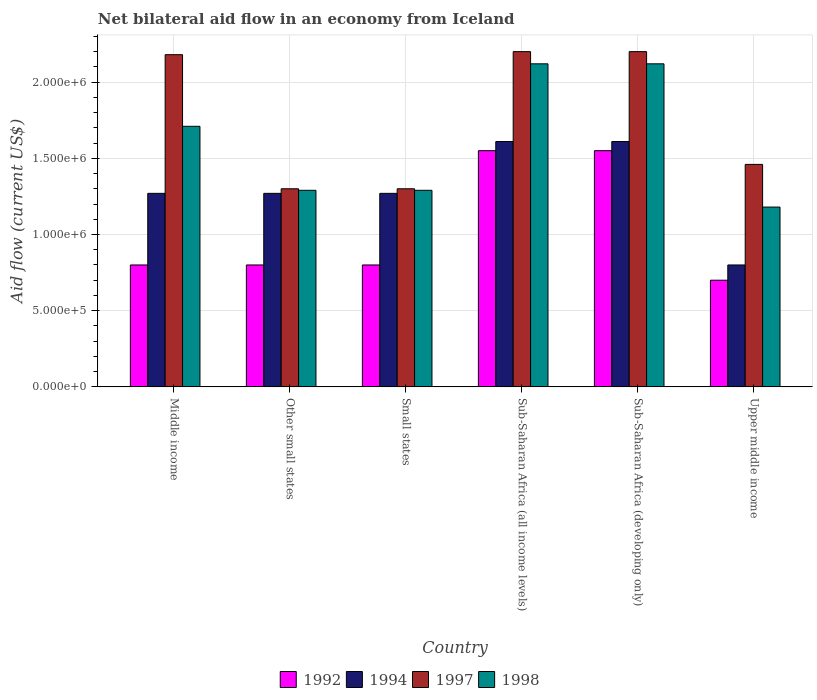Are the number of bars on each tick of the X-axis equal?
Make the answer very short. Yes. How many bars are there on the 1st tick from the left?
Give a very brief answer. 4. What is the label of the 5th group of bars from the left?
Offer a very short reply. Sub-Saharan Africa (developing only). What is the net bilateral aid flow in 1994 in Small states?
Give a very brief answer. 1.27e+06. Across all countries, what is the maximum net bilateral aid flow in 1997?
Your answer should be very brief. 2.20e+06. Across all countries, what is the minimum net bilateral aid flow in 1992?
Provide a succinct answer. 7.00e+05. In which country was the net bilateral aid flow in 1998 maximum?
Make the answer very short. Sub-Saharan Africa (all income levels). In which country was the net bilateral aid flow in 1994 minimum?
Make the answer very short. Upper middle income. What is the total net bilateral aid flow in 1998 in the graph?
Provide a succinct answer. 9.71e+06. What is the difference between the net bilateral aid flow in 1994 in Small states and the net bilateral aid flow in 1997 in Middle income?
Ensure brevity in your answer.  -9.10e+05. What is the average net bilateral aid flow in 1998 per country?
Offer a terse response. 1.62e+06. What is the difference between the net bilateral aid flow of/in 1994 and net bilateral aid flow of/in 1997 in Sub-Saharan Africa (all income levels)?
Your answer should be very brief. -5.90e+05. In how many countries, is the net bilateral aid flow in 1998 greater than 1300000 US$?
Ensure brevity in your answer.  3. What is the ratio of the net bilateral aid flow in 1998 in Middle income to that in Sub-Saharan Africa (developing only)?
Provide a short and direct response. 0.81. What is the difference between the highest and the second highest net bilateral aid flow in 1998?
Ensure brevity in your answer.  4.10e+05. What is the difference between the highest and the lowest net bilateral aid flow in 1997?
Offer a terse response. 9.00e+05. In how many countries, is the net bilateral aid flow in 1998 greater than the average net bilateral aid flow in 1998 taken over all countries?
Keep it short and to the point. 3. Is the sum of the net bilateral aid flow in 1997 in Small states and Upper middle income greater than the maximum net bilateral aid flow in 1998 across all countries?
Ensure brevity in your answer.  Yes. What does the 4th bar from the left in Other small states represents?
Your answer should be very brief. 1998. What does the 3rd bar from the right in Sub-Saharan Africa (all income levels) represents?
Provide a succinct answer. 1994. Are all the bars in the graph horizontal?
Make the answer very short. No. Does the graph contain grids?
Make the answer very short. Yes. How many legend labels are there?
Offer a terse response. 4. How are the legend labels stacked?
Your answer should be compact. Horizontal. What is the title of the graph?
Provide a short and direct response. Net bilateral aid flow in an economy from Iceland. Does "1993" appear as one of the legend labels in the graph?
Keep it short and to the point. No. What is the Aid flow (current US$) in 1994 in Middle income?
Keep it short and to the point. 1.27e+06. What is the Aid flow (current US$) of 1997 in Middle income?
Give a very brief answer. 2.18e+06. What is the Aid flow (current US$) in 1998 in Middle income?
Offer a terse response. 1.71e+06. What is the Aid flow (current US$) of 1994 in Other small states?
Provide a succinct answer. 1.27e+06. What is the Aid flow (current US$) of 1997 in Other small states?
Ensure brevity in your answer.  1.30e+06. What is the Aid flow (current US$) of 1998 in Other small states?
Your response must be concise. 1.29e+06. What is the Aid flow (current US$) in 1994 in Small states?
Your answer should be very brief. 1.27e+06. What is the Aid flow (current US$) of 1997 in Small states?
Provide a short and direct response. 1.30e+06. What is the Aid flow (current US$) of 1998 in Small states?
Offer a very short reply. 1.29e+06. What is the Aid flow (current US$) in 1992 in Sub-Saharan Africa (all income levels)?
Keep it short and to the point. 1.55e+06. What is the Aid flow (current US$) in 1994 in Sub-Saharan Africa (all income levels)?
Offer a very short reply. 1.61e+06. What is the Aid flow (current US$) in 1997 in Sub-Saharan Africa (all income levels)?
Keep it short and to the point. 2.20e+06. What is the Aid flow (current US$) in 1998 in Sub-Saharan Africa (all income levels)?
Provide a succinct answer. 2.12e+06. What is the Aid flow (current US$) of 1992 in Sub-Saharan Africa (developing only)?
Keep it short and to the point. 1.55e+06. What is the Aid flow (current US$) in 1994 in Sub-Saharan Africa (developing only)?
Give a very brief answer. 1.61e+06. What is the Aid flow (current US$) of 1997 in Sub-Saharan Africa (developing only)?
Your answer should be very brief. 2.20e+06. What is the Aid flow (current US$) in 1998 in Sub-Saharan Africa (developing only)?
Your answer should be very brief. 2.12e+06. What is the Aid flow (current US$) in 1994 in Upper middle income?
Provide a succinct answer. 8.00e+05. What is the Aid flow (current US$) in 1997 in Upper middle income?
Your response must be concise. 1.46e+06. What is the Aid flow (current US$) of 1998 in Upper middle income?
Offer a very short reply. 1.18e+06. Across all countries, what is the maximum Aid flow (current US$) in 1992?
Offer a terse response. 1.55e+06. Across all countries, what is the maximum Aid flow (current US$) of 1994?
Give a very brief answer. 1.61e+06. Across all countries, what is the maximum Aid flow (current US$) in 1997?
Keep it short and to the point. 2.20e+06. Across all countries, what is the maximum Aid flow (current US$) of 1998?
Provide a short and direct response. 2.12e+06. Across all countries, what is the minimum Aid flow (current US$) in 1992?
Offer a very short reply. 7.00e+05. Across all countries, what is the minimum Aid flow (current US$) of 1997?
Your answer should be compact. 1.30e+06. Across all countries, what is the minimum Aid flow (current US$) in 1998?
Make the answer very short. 1.18e+06. What is the total Aid flow (current US$) of 1992 in the graph?
Your answer should be compact. 6.20e+06. What is the total Aid flow (current US$) of 1994 in the graph?
Provide a short and direct response. 7.83e+06. What is the total Aid flow (current US$) in 1997 in the graph?
Your answer should be very brief. 1.06e+07. What is the total Aid flow (current US$) in 1998 in the graph?
Give a very brief answer. 9.71e+06. What is the difference between the Aid flow (current US$) in 1992 in Middle income and that in Other small states?
Ensure brevity in your answer.  0. What is the difference between the Aid flow (current US$) of 1997 in Middle income and that in Other small states?
Provide a short and direct response. 8.80e+05. What is the difference between the Aid flow (current US$) in 1998 in Middle income and that in Other small states?
Offer a terse response. 4.20e+05. What is the difference between the Aid flow (current US$) in 1992 in Middle income and that in Small states?
Your response must be concise. 0. What is the difference between the Aid flow (current US$) in 1997 in Middle income and that in Small states?
Your answer should be compact. 8.80e+05. What is the difference between the Aid flow (current US$) in 1992 in Middle income and that in Sub-Saharan Africa (all income levels)?
Keep it short and to the point. -7.50e+05. What is the difference between the Aid flow (current US$) in 1994 in Middle income and that in Sub-Saharan Africa (all income levels)?
Keep it short and to the point. -3.40e+05. What is the difference between the Aid flow (current US$) in 1997 in Middle income and that in Sub-Saharan Africa (all income levels)?
Provide a succinct answer. -2.00e+04. What is the difference between the Aid flow (current US$) in 1998 in Middle income and that in Sub-Saharan Africa (all income levels)?
Ensure brevity in your answer.  -4.10e+05. What is the difference between the Aid flow (current US$) in 1992 in Middle income and that in Sub-Saharan Africa (developing only)?
Your answer should be compact. -7.50e+05. What is the difference between the Aid flow (current US$) of 1994 in Middle income and that in Sub-Saharan Africa (developing only)?
Make the answer very short. -3.40e+05. What is the difference between the Aid flow (current US$) in 1997 in Middle income and that in Sub-Saharan Africa (developing only)?
Your response must be concise. -2.00e+04. What is the difference between the Aid flow (current US$) of 1998 in Middle income and that in Sub-Saharan Africa (developing only)?
Your answer should be very brief. -4.10e+05. What is the difference between the Aid flow (current US$) of 1994 in Middle income and that in Upper middle income?
Keep it short and to the point. 4.70e+05. What is the difference between the Aid flow (current US$) in 1997 in Middle income and that in Upper middle income?
Your answer should be very brief. 7.20e+05. What is the difference between the Aid flow (current US$) in 1998 in Middle income and that in Upper middle income?
Provide a succinct answer. 5.30e+05. What is the difference between the Aid flow (current US$) of 1998 in Other small states and that in Small states?
Provide a short and direct response. 0. What is the difference between the Aid flow (current US$) of 1992 in Other small states and that in Sub-Saharan Africa (all income levels)?
Your response must be concise. -7.50e+05. What is the difference between the Aid flow (current US$) in 1997 in Other small states and that in Sub-Saharan Africa (all income levels)?
Provide a succinct answer. -9.00e+05. What is the difference between the Aid flow (current US$) of 1998 in Other small states and that in Sub-Saharan Africa (all income levels)?
Your response must be concise. -8.30e+05. What is the difference between the Aid flow (current US$) in 1992 in Other small states and that in Sub-Saharan Africa (developing only)?
Your answer should be compact. -7.50e+05. What is the difference between the Aid flow (current US$) of 1994 in Other small states and that in Sub-Saharan Africa (developing only)?
Keep it short and to the point. -3.40e+05. What is the difference between the Aid flow (current US$) of 1997 in Other small states and that in Sub-Saharan Africa (developing only)?
Provide a short and direct response. -9.00e+05. What is the difference between the Aid flow (current US$) of 1998 in Other small states and that in Sub-Saharan Africa (developing only)?
Your response must be concise. -8.30e+05. What is the difference between the Aid flow (current US$) in 1992 in Other small states and that in Upper middle income?
Provide a succinct answer. 1.00e+05. What is the difference between the Aid flow (current US$) of 1994 in Other small states and that in Upper middle income?
Your answer should be very brief. 4.70e+05. What is the difference between the Aid flow (current US$) of 1997 in Other small states and that in Upper middle income?
Offer a terse response. -1.60e+05. What is the difference between the Aid flow (current US$) in 1992 in Small states and that in Sub-Saharan Africa (all income levels)?
Your answer should be very brief. -7.50e+05. What is the difference between the Aid flow (current US$) in 1997 in Small states and that in Sub-Saharan Africa (all income levels)?
Give a very brief answer. -9.00e+05. What is the difference between the Aid flow (current US$) of 1998 in Small states and that in Sub-Saharan Africa (all income levels)?
Your answer should be compact. -8.30e+05. What is the difference between the Aid flow (current US$) of 1992 in Small states and that in Sub-Saharan Africa (developing only)?
Give a very brief answer. -7.50e+05. What is the difference between the Aid flow (current US$) in 1997 in Small states and that in Sub-Saharan Africa (developing only)?
Offer a very short reply. -9.00e+05. What is the difference between the Aid flow (current US$) of 1998 in Small states and that in Sub-Saharan Africa (developing only)?
Offer a terse response. -8.30e+05. What is the difference between the Aid flow (current US$) in 1998 in Small states and that in Upper middle income?
Provide a short and direct response. 1.10e+05. What is the difference between the Aid flow (current US$) in 1992 in Sub-Saharan Africa (all income levels) and that in Sub-Saharan Africa (developing only)?
Provide a short and direct response. 0. What is the difference between the Aid flow (current US$) of 1998 in Sub-Saharan Africa (all income levels) and that in Sub-Saharan Africa (developing only)?
Keep it short and to the point. 0. What is the difference between the Aid flow (current US$) of 1992 in Sub-Saharan Africa (all income levels) and that in Upper middle income?
Your response must be concise. 8.50e+05. What is the difference between the Aid flow (current US$) of 1994 in Sub-Saharan Africa (all income levels) and that in Upper middle income?
Your response must be concise. 8.10e+05. What is the difference between the Aid flow (current US$) in 1997 in Sub-Saharan Africa (all income levels) and that in Upper middle income?
Keep it short and to the point. 7.40e+05. What is the difference between the Aid flow (current US$) of 1998 in Sub-Saharan Africa (all income levels) and that in Upper middle income?
Offer a terse response. 9.40e+05. What is the difference between the Aid flow (current US$) in 1992 in Sub-Saharan Africa (developing only) and that in Upper middle income?
Keep it short and to the point. 8.50e+05. What is the difference between the Aid flow (current US$) of 1994 in Sub-Saharan Africa (developing only) and that in Upper middle income?
Keep it short and to the point. 8.10e+05. What is the difference between the Aid flow (current US$) of 1997 in Sub-Saharan Africa (developing only) and that in Upper middle income?
Your answer should be very brief. 7.40e+05. What is the difference between the Aid flow (current US$) of 1998 in Sub-Saharan Africa (developing only) and that in Upper middle income?
Give a very brief answer. 9.40e+05. What is the difference between the Aid flow (current US$) in 1992 in Middle income and the Aid flow (current US$) in 1994 in Other small states?
Your answer should be very brief. -4.70e+05. What is the difference between the Aid flow (current US$) in 1992 in Middle income and the Aid flow (current US$) in 1997 in Other small states?
Ensure brevity in your answer.  -5.00e+05. What is the difference between the Aid flow (current US$) of 1992 in Middle income and the Aid flow (current US$) of 1998 in Other small states?
Ensure brevity in your answer.  -4.90e+05. What is the difference between the Aid flow (current US$) in 1997 in Middle income and the Aid flow (current US$) in 1998 in Other small states?
Offer a terse response. 8.90e+05. What is the difference between the Aid flow (current US$) in 1992 in Middle income and the Aid flow (current US$) in 1994 in Small states?
Provide a succinct answer. -4.70e+05. What is the difference between the Aid flow (current US$) in 1992 in Middle income and the Aid flow (current US$) in 1997 in Small states?
Provide a short and direct response. -5.00e+05. What is the difference between the Aid flow (current US$) of 1992 in Middle income and the Aid flow (current US$) of 1998 in Small states?
Make the answer very short. -4.90e+05. What is the difference between the Aid flow (current US$) of 1994 in Middle income and the Aid flow (current US$) of 1998 in Small states?
Provide a succinct answer. -2.00e+04. What is the difference between the Aid flow (current US$) in 1997 in Middle income and the Aid flow (current US$) in 1998 in Small states?
Your response must be concise. 8.90e+05. What is the difference between the Aid flow (current US$) of 1992 in Middle income and the Aid flow (current US$) of 1994 in Sub-Saharan Africa (all income levels)?
Your response must be concise. -8.10e+05. What is the difference between the Aid flow (current US$) of 1992 in Middle income and the Aid flow (current US$) of 1997 in Sub-Saharan Africa (all income levels)?
Give a very brief answer. -1.40e+06. What is the difference between the Aid flow (current US$) in 1992 in Middle income and the Aid flow (current US$) in 1998 in Sub-Saharan Africa (all income levels)?
Your answer should be very brief. -1.32e+06. What is the difference between the Aid flow (current US$) in 1994 in Middle income and the Aid flow (current US$) in 1997 in Sub-Saharan Africa (all income levels)?
Your response must be concise. -9.30e+05. What is the difference between the Aid flow (current US$) in 1994 in Middle income and the Aid flow (current US$) in 1998 in Sub-Saharan Africa (all income levels)?
Provide a short and direct response. -8.50e+05. What is the difference between the Aid flow (current US$) in 1992 in Middle income and the Aid flow (current US$) in 1994 in Sub-Saharan Africa (developing only)?
Provide a short and direct response. -8.10e+05. What is the difference between the Aid flow (current US$) in 1992 in Middle income and the Aid flow (current US$) in 1997 in Sub-Saharan Africa (developing only)?
Provide a succinct answer. -1.40e+06. What is the difference between the Aid flow (current US$) in 1992 in Middle income and the Aid flow (current US$) in 1998 in Sub-Saharan Africa (developing only)?
Give a very brief answer. -1.32e+06. What is the difference between the Aid flow (current US$) of 1994 in Middle income and the Aid flow (current US$) of 1997 in Sub-Saharan Africa (developing only)?
Your answer should be very brief. -9.30e+05. What is the difference between the Aid flow (current US$) of 1994 in Middle income and the Aid flow (current US$) of 1998 in Sub-Saharan Africa (developing only)?
Provide a succinct answer. -8.50e+05. What is the difference between the Aid flow (current US$) in 1997 in Middle income and the Aid flow (current US$) in 1998 in Sub-Saharan Africa (developing only)?
Your response must be concise. 6.00e+04. What is the difference between the Aid flow (current US$) of 1992 in Middle income and the Aid flow (current US$) of 1997 in Upper middle income?
Make the answer very short. -6.60e+05. What is the difference between the Aid flow (current US$) in 1992 in Middle income and the Aid flow (current US$) in 1998 in Upper middle income?
Offer a terse response. -3.80e+05. What is the difference between the Aid flow (current US$) of 1994 in Middle income and the Aid flow (current US$) of 1997 in Upper middle income?
Make the answer very short. -1.90e+05. What is the difference between the Aid flow (current US$) of 1994 in Middle income and the Aid flow (current US$) of 1998 in Upper middle income?
Offer a terse response. 9.00e+04. What is the difference between the Aid flow (current US$) in 1997 in Middle income and the Aid flow (current US$) in 1998 in Upper middle income?
Your answer should be compact. 1.00e+06. What is the difference between the Aid flow (current US$) of 1992 in Other small states and the Aid flow (current US$) of 1994 in Small states?
Give a very brief answer. -4.70e+05. What is the difference between the Aid flow (current US$) in 1992 in Other small states and the Aid flow (current US$) in 1997 in Small states?
Provide a short and direct response. -5.00e+05. What is the difference between the Aid flow (current US$) of 1992 in Other small states and the Aid flow (current US$) of 1998 in Small states?
Provide a succinct answer. -4.90e+05. What is the difference between the Aid flow (current US$) in 1994 in Other small states and the Aid flow (current US$) in 1997 in Small states?
Provide a succinct answer. -3.00e+04. What is the difference between the Aid flow (current US$) of 1994 in Other small states and the Aid flow (current US$) of 1998 in Small states?
Provide a short and direct response. -2.00e+04. What is the difference between the Aid flow (current US$) of 1992 in Other small states and the Aid flow (current US$) of 1994 in Sub-Saharan Africa (all income levels)?
Offer a very short reply. -8.10e+05. What is the difference between the Aid flow (current US$) of 1992 in Other small states and the Aid flow (current US$) of 1997 in Sub-Saharan Africa (all income levels)?
Give a very brief answer. -1.40e+06. What is the difference between the Aid flow (current US$) of 1992 in Other small states and the Aid flow (current US$) of 1998 in Sub-Saharan Africa (all income levels)?
Give a very brief answer. -1.32e+06. What is the difference between the Aid flow (current US$) in 1994 in Other small states and the Aid flow (current US$) in 1997 in Sub-Saharan Africa (all income levels)?
Keep it short and to the point. -9.30e+05. What is the difference between the Aid flow (current US$) of 1994 in Other small states and the Aid flow (current US$) of 1998 in Sub-Saharan Africa (all income levels)?
Provide a succinct answer. -8.50e+05. What is the difference between the Aid flow (current US$) in 1997 in Other small states and the Aid flow (current US$) in 1998 in Sub-Saharan Africa (all income levels)?
Make the answer very short. -8.20e+05. What is the difference between the Aid flow (current US$) of 1992 in Other small states and the Aid flow (current US$) of 1994 in Sub-Saharan Africa (developing only)?
Your answer should be very brief. -8.10e+05. What is the difference between the Aid flow (current US$) of 1992 in Other small states and the Aid flow (current US$) of 1997 in Sub-Saharan Africa (developing only)?
Give a very brief answer. -1.40e+06. What is the difference between the Aid flow (current US$) in 1992 in Other small states and the Aid flow (current US$) in 1998 in Sub-Saharan Africa (developing only)?
Provide a succinct answer. -1.32e+06. What is the difference between the Aid flow (current US$) in 1994 in Other small states and the Aid flow (current US$) in 1997 in Sub-Saharan Africa (developing only)?
Your answer should be very brief. -9.30e+05. What is the difference between the Aid flow (current US$) of 1994 in Other small states and the Aid flow (current US$) of 1998 in Sub-Saharan Africa (developing only)?
Provide a succinct answer. -8.50e+05. What is the difference between the Aid flow (current US$) in 1997 in Other small states and the Aid flow (current US$) in 1998 in Sub-Saharan Africa (developing only)?
Make the answer very short. -8.20e+05. What is the difference between the Aid flow (current US$) of 1992 in Other small states and the Aid flow (current US$) of 1994 in Upper middle income?
Offer a terse response. 0. What is the difference between the Aid flow (current US$) of 1992 in Other small states and the Aid flow (current US$) of 1997 in Upper middle income?
Provide a succinct answer. -6.60e+05. What is the difference between the Aid flow (current US$) of 1992 in Other small states and the Aid flow (current US$) of 1998 in Upper middle income?
Offer a terse response. -3.80e+05. What is the difference between the Aid flow (current US$) of 1992 in Small states and the Aid flow (current US$) of 1994 in Sub-Saharan Africa (all income levels)?
Your answer should be very brief. -8.10e+05. What is the difference between the Aid flow (current US$) of 1992 in Small states and the Aid flow (current US$) of 1997 in Sub-Saharan Africa (all income levels)?
Offer a very short reply. -1.40e+06. What is the difference between the Aid flow (current US$) of 1992 in Small states and the Aid flow (current US$) of 1998 in Sub-Saharan Africa (all income levels)?
Provide a succinct answer. -1.32e+06. What is the difference between the Aid flow (current US$) of 1994 in Small states and the Aid flow (current US$) of 1997 in Sub-Saharan Africa (all income levels)?
Give a very brief answer. -9.30e+05. What is the difference between the Aid flow (current US$) of 1994 in Small states and the Aid flow (current US$) of 1998 in Sub-Saharan Africa (all income levels)?
Your answer should be very brief. -8.50e+05. What is the difference between the Aid flow (current US$) in 1997 in Small states and the Aid flow (current US$) in 1998 in Sub-Saharan Africa (all income levels)?
Your answer should be compact. -8.20e+05. What is the difference between the Aid flow (current US$) in 1992 in Small states and the Aid flow (current US$) in 1994 in Sub-Saharan Africa (developing only)?
Provide a succinct answer. -8.10e+05. What is the difference between the Aid flow (current US$) in 1992 in Small states and the Aid flow (current US$) in 1997 in Sub-Saharan Africa (developing only)?
Your answer should be very brief. -1.40e+06. What is the difference between the Aid flow (current US$) in 1992 in Small states and the Aid flow (current US$) in 1998 in Sub-Saharan Africa (developing only)?
Offer a very short reply. -1.32e+06. What is the difference between the Aid flow (current US$) of 1994 in Small states and the Aid flow (current US$) of 1997 in Sub-Saharan Africa (developing only)?
Provide a short and direct response. -9.30e+05. What is the difference between the Aid flow (current US$) in 1994 in Small states and the Aid flow (current US$) in 1998 in Sub-Saharan Africa (developing only)?
Your answer should be very brief. -8.50e+05. What is the difference between the Aid flow (current US$) of 1997 in Small states and the Aid flow (current US$) of 1998 in Sub-Saharan Africa (developing only)?
Provide a succinct answer. -8.20e+05. What is the difference between the Aid flow (current US$) of 1992 in Small states and the Aid flow (current US$) of 1997 in Upper middle income?
Offer a very short reply. -6.60e+05. What is the difference between the Aid flow (current US$) in 1992 in Small states and the Aid flow (current US$) in 1998 in Upper middle income?
Provide a short and direct response. -3.80e+05. What is the difference between the Aid flow (current US$) of 1994 in Small states and the Aid flow (current US$) of 1997 in Upper middle income?
Your answer should be very brief. -1.90e+05. What is the difference between the Aid flow (current US$) of 1997 in Small states and the Aid flow (current US$) of 1998 in Upper middle income?
Your answer should be very brief. 1.20e+05. What is the difference between the Aid flow (current US$) of 1992 in Sub-Saharan Africa (all income levels) and the Aid flow (current US$) of 1997 in Sub-Saharan Africa (developing only)?
Offer a terse response. -6.50e+05. What is the difference between the Aid flow (current US$) in 1992 in Sub-Saharan Africa (all income levels) and the Aid flow (current US$) in 1998 in Sub-Saharan Africa (developing only)?
Offer a terse response. -5.70e+05. What is the difference between the Aid flow (current US$) of 1994 in Sub-Saharan Africa (all income levels) and the Aid flow (current US$) of 1997 in Sub-Saharan Africa (developing only)?
Give a very brief answer. -5.90e+05. What is the difference between the Aid flow (current US$) in 1994 in Sub-Saharan Africa (all income levels) and the Aid flow (current US$) in 1998 in Sub-Saharan Africa (developing only)?
Make the answer very short. -5.10e+05. What is the difference between the Aid flow (current US$) in 1992 in Sub-Saharan Africa (all income levels) and the Aid flow (current US$) in 1994 in Upper middle income?
Make the answer very short. 7.50e+05. What is the difference between the Aid flow (current US$) in 1992 in Sub-Saharan Africa (all income levels) and the Aid flow (current US$) in 1997 in Upper middle income?
Your response must be concise. 9.00e+04. What is the difference between the Aid flow (current US$) of 1997 in Sub-Saharan Africa (all income levels) and the Aid flow (current US$) of 1998 in Upper middle income?
Provide a short and direct response. 1.02e+06. What is the difference between the Aid flow (current US$) in 1992 in Sub-Saharan Africa (developing only) and the Aid flow (current US$) in 1994 in Upper middle income?
Your response must be concise. 7.50e+05. What is the difference between the Aid flow (current US$) in 1992 in Sub-Saharan Africa (developing only) and the Aid flow (current US$) in 1997 in Upper middle income?
Your answer should be very brief. 9.00e+04. What is the difference between the Aid flow (current US$) of 1994 in Sub-Saharan Africa (developing only) and the Aid flow (current US$) of 1998 in Upper middle income?
Make the answer very short. 4.30e+05. What is the difference between the Aid flow (current US$) of 1997 in Sub-Saharan Africa (developing only) and the Aid flow (current US$) of 1998 in Upper middle income?
Offer a terse response. 1.02e+06. What is the average Aid flow (current US$) of 1992 per country?
Provide a succinct answer. 1.03e+06. What is the average Aid flow (current US$) of 1994 per country?
Offer a terse response. 1.30e+06. What is the average Aid flow (current US$) of 1997 per country?
Keep it short and to the point. 1.77e+06. What is the average Aid flow (current US$) in 1998 per country?
Give a very brief answer. 1.62e+06. What is the difference between the Aid flow (current US$) in 1992 and Aid flow (current US$) in 1994 in Middle income?
Your answer should be compact. -4.70e+05. What is the difference between the Aid flow (current US$) of 1992 and Aid flow (current US$) of 1997 in Middle income?
Offer a very short reply. -1.38e+06. What is the difference between the Aid flow (current US$) of 1992 and Aid flow (current US$) of 1998 in Middle income?
Provide a succinct answer. -9.10e+05. What is the difference between the Aid flow (current US$) of 1994 and Aid flow (current US$) of 1997 in Middle income?
Give a very brief answer. -9.10e+05. What is the difference between the Aid flow (current US$) of 1994 and Aid flow (current US$) of 1998 in Middle income?
Make the answer very short. -4.40e+05. What is the difference between the Aid flow (current US$) of 1997 and Aid flow (current US$) of 1998 in Middle income?
Give a very brief answer. 4.70e+05. What is the difference between the Aid flow (current US$) in 1992 and Aid flow (current US$) in 1994 in Other small states?
Ensure brevity in your answer.  -4.70e+05. What is the difference between the Aid flow (current US$) of 1992 and Aid flow (current US$) of 1997 in Other small states?
Your answer should be very brief. -5.00e+05. What is the difference between the Aid flow (current US$) of 1992 and Aid flow (current US$) of 1998 in Other small states?
Offer a terse response. -4.90e+05. What is the difference between the Aid flow (current US$) in 1992 and Aid flow (current US$) in 1994 in Small states?
Offer a terse response. -4.70e+05. What is the difference between the Aid flow (current US$) in 1992 and Aid flow (current US$) in 1997 in Small states?
Give a very brief answer. -5.00e+05. What is the difference between the Aid flow (current US$) in 1992 and Aid flow (current US$) in 1998 in Small states?
Your response must be concise. -4.90e+05. What is the difference between the Aid flow (current US$) of 1994 and Aid flow (current US$) of 1997 in Small states?
Ensure brevity in your answer.  -3.00e+04. What is the difference between the Aid flow (current US$) of 1997 and Aid flow (current US$) of 1998 in Small states?
Offer a very short reply. 10000. What is the difference between the Aid flow (current US$) of 1992 and Aid flow (current US$) of 1994 in Sub-Saharan Africa (all income levels)?
Provide a succinct answer. -6.00e+04. What is the difference between the Aid flow (current US$) in 1992 and Aid flow (current US$) in 1997 in Sub-Saharan Africa (all income levels)?
Ensure brevity in your answer.  -6.50e+05. What is the difference between the Aid flow (current US$) in 1992 and Aid flow (current US$) in 1998 in Sub-Saharan Africa (all income levels)?
Ensure brevity in your answer.  -5.70e+05. What is the difference between the Aid flow (current US$) in 1994 and Aid flow (current US$) in 1997 in Sub-Saharan Africa (all income levels)?
Offer a very short reply. -5.90e+05. What is the difference between the Aid flow (current US$) in 1994 and Aid flow (current US$) in 1998 in Sub-Saharan Africa (all income levels)?
Give a very brief answer. -5.10e+05. What is the difference between the Aid flow (current US$) of 1992 and Aid flow (current US$) of 1997 in Sub-Saharan Africa (developing only)?
Your response must be concise. -6.50e+05. What is the difference between the Aid flow (current US$) of 1992 and Aid flow (current US$) of 1998 in Sub-Saharan Africa (developing only)?
Ensure brevity in your answer.  -5.70e+05. What is the difference between the Aid flow (current US$) in 1994 and Aid flow (current US$) in 1997 in Sub-Saharan Africa (developing only)?
Ensure brevity in your answer.  -5.90e+05. What is the difference between the Aid flow (current US$) of 1994 and Aid flow (current US$) of 1998 in Sub-Saharan Africa (developing only)?
Offer a very short reply. -5.10e+05. What is the difference between the Aid flow (current US$) of 1997 and Aid flow (current US$) of 1998 in Sub-Saharan Africa (developing only)?
Offer a terse response. 8.00e+04. What is the difference between the Aid flow (current US$) of 1992 and Aid flow (current US$) of 1997 in Upper middle income?
Give a very brief answer. -7.60e+05. What is the difference between the Aid flow (current US$) of 1992 and Aid flow (current US$) of 1998 in Upper middle income?
Offer a terse response. -4.80e+05. What is the difference between the Aid flow (current US$) in 1994 and Aid flow (current US$) in 1997 in Upper middle income?
Give a very brief answer. -6.60e+05. What is the difference between the Aid flow (current US$) in 1994 and Aid flow (current US$) in 1998 in Upper middle income?
Provide a succinct answer. -3.80e+05. What is the ratio of the Aid flow (current US$) in 1992 in Middle income to that in Other small states?
Make the answer very short. 1. What is the ratio of the Aid flow (current US$) in 1994 in Middle income to that in Other small states?
Ensure brevity in your answer.  1. What is the ratio of the Aid flow (current US$) in 1997 in Middle income to that in Other small states?
Offer a terse response. 1.68. What is the ratio of the Aid flow (current US$) in 1998 in Middle income to that in Other small states?
Your answer should be very brief. 1.33. What is the ratio of the Aid flow (current US$) of 1992 in Middle income to that in Small states?
Offer a terse response. 1. What is the ratio of the Aid flow (current US$) of 1994 in Middle income to that in Small states?
Keep it short and to the point. 1. What is the ratio of the Aid flow (current US$) of 1997 in Middle income to that in Small states?
Keep it short and to the point. 1.68. What is the ratio of the Aid flow (current US$) of 1998 in Middle income to that in Small states?
Your response must be concise. 1.33. What is the ratio of the Aid flow (current US$) of 1992 in Middle income to that in Sub-Saharan Africa (all income levels)?
Your answer should be very brief. 0.52. What is the ratio of the Aid flow (current US$) in 1994 in Middle income to that in Sub-Saharan Africa (all income levels)?
Your answer should be very brief. 0.79. What is the ratio of the Aid flow (current US$) in 1997 in Middle income to that in Sub-Saharan Africa (all income levels)?
Provide a succinct answer. 0.99. What is the ratio of the Aid flow (current US$) in 1998 in Middle income to that in Sub-Saharan Africa (all income levels)?
Give a very brief answer. 0.81. What is the ratio of the Aid flow (current US$) of 1992 in Middle income to that in Sub-Saharan Africa (developing only)?
Keep it short and to the point. 0.52. What is the ratio of the Aid flow (current US$) of 1994 in Middle income to that in Sub-Saharan Africa (developing only)?
Offer a terse response. 0.79. What is the ratio of the Aid flow (current US$) in 1997 in Middle income to that in Sub-Saharan Africa (developing only)?
Offer a very short reply. 0.99. What is the ratio of the Aid flow (current US$) in 1998 in Middle income to that in Sub-Saharan Africa (developing only)?
Offer a very short reply. 0.81. What is the ratio of the Aid flow (current US$) in 1992 in Middle income to that in Upper middle income?
Make the answer very short. 1.14. What is the ratio of the Aid flow (current US$) in 1994 in Middle income to that in Upper middle income?
Ensure brevity in your answer.  1.59. What is the ratio of the Aid flow (current US$) in 1997 in Middle income to that in Upper middle income?
Keep it short and to the point. 1.49. What is the ratio of the Aid flow (current US$) of 1998 in Middle income to that in Upper middle income?
Offer a very short reply. 1.45. What is the ratio of the Aid flow (current US$) in 1997 in Other small states to that in Small states?
Offer a very short reply. 1. What is the ratio of the Aid flow (current US$) of 1998 in Other small states to that in Small states?
Keep it short and to the point. 1. What is the ratio of the Aid flow (current US$) of 1992 in Other small states to that in Sub-Saharan Africa (all income levels)?
Make the answer very short. 0.52. What is the ratio of the Aid flow (current US$) in 1994 in Other small states to that in Sub-Saharan Africa (all income levels)?
Provide a short and direct response. 0.79. What is the ratio of the Aid flow (current US$) of 1997 in Other small states to that in Sub-Saharan Africa (all income levels)?
Your answer should be very brief. 0.59. What is the ratio of the Aid flow (current US$) in 1998 in Other small states to that in Sub-Saharan Africa (all income levels)?
Keep it short and to the point. 0.61. What is the ratio of the Aid flow (current US$) in 1992 in Other small states to that in Sub-Saharan Africa (developing only)?
Provide a succinct answer. 0.52. What is the ratio of the Aid flow (current US$) in 1994 in Other small states to that in Sub-Saharan Africa (developing only)?
Give a very brief answer. 0.79. What is the ratio of the Aid flow (current US$) of 1997 in Other small states to that in Sub-Saharan Africa (developing only)?
Your response must be concise. 0.59. What is the ratio of the Aid flow (current US$) of 1998 in Other small states to that in Sub-Saharan Africa (developing only)?
Keep it short and to the point. 0.61. What is the ratio of the Aid flow (current US$) of 1994 in Other small states to that in Upper middle income?
Offer a terse response. 1.59. What is the ratio of the Aid flow (current US$) of 1997 in Other small states to that in Upper middle income?
Your answer should be very brief. 0.89. What is the ratio of the Aid flow (current US$) of 1998 in Other small states to that in Upper middle income?
Keep it short and to the point. 1.09. What is the ratio of the Aid flow (current US$) in 1992 in Small states to that in Sub-Saharan Africa (all income levels)?
Offer a very short reply. 0.52. What is the ratio of the Aid flow (current US$) in 1994 in Small states to that in Sub-Saharan Africa (all income levels)?
Give a very brief answer. 0.79. What is the ratio of the Aid flow (current US$) of 1997 in Small states to that in Sub-Saharan Africa (all income levels)?
Keep it short and to the point. 0.59. What is the ratio of the Aid flow (current US$) in 1998 in Small states to that in Sub-Saharan Africa (all income levels)?
Give a very brief answer. 0.61. What is the ratio of the Aid flow (current US$) of 1992 in Small states to that in Sub-Saharan Africa (developing only)?
Provide a succinct answer. 0.52. What is the ratio of the Aid flow (current US$) of 1994 in Small states to that in Sub-Saharan Africa (developing only)?
Your answer should be compact. 0.79. What is the ratio of the Aid flow (current US$) in 1997 in Small states to that in Sub-Saharan Africa (developing only)?
Offer a very short reply. 0.59. What is the ratio of the Aid flow (current US$) of 1998 in Small states to that in Sub-Saharan Africa (developing only)?
Keep it short and to the point. 0.61. What is the ratio of the Aid flow (current US$) of 1994 in Small states to that in Upper middle income?
Your answer should be compact. 1.59. What is the ratio of the Aid flow (current US$) of 1997 in Small states to that in Upper middle income?
Make the answer very short. 0.89. What is the ratio of the Aid flow (current US$) in 1998 in Small states to that in Upper middle income?
Make the answer very short. 1.09. What is the ratio of the Aid flow (current US$) in 1992 in Sub-Saharan Africa (all income levels) to that in Upper middle income?
Offer a terse response. 2.21. What is the ratio of the Aid flow (current US$) of 1994 in Sub-Saharan Africa (all income levels) to that in Upper middle income?
Provide a short and direct response. 2.01. What is the ratio of the Aid flow (current US$) of 1997 in Sub-Saharan Africa (all income levels) to that in Upper middle income?
Offer a very short reply. 1.51. What is the ratio of the Aid flow (current US$) in 1998 in Sub-Saharan Africa (all income levels) to that in Upper middle income?
Keep it short and to the point. 1.8. What is the ratio of the Aid flow (current US$) of 1992 in Sub-Saharan Africa (developing only) to that in Upper middle income?
Keep it short and to the point. 2.21. What is the ratio of the Aid flow (current US$) in 1994 in Sub-Saharan Africa (developing only) to that in Upper middle income?
Your response must be concise. 2.01. What is the ratio of the Aid flow (current US$) in 1997 in Sub-Saharan Africa (developing only) to that in Upper middle income?
Give a very brief answer. 1.51. What is the ratio of the Aid flow (current US$) in 1998 in Sub-Saharan Africa (developing only) to that in Upper middle income?
Provide a succinct answer. 1.8. What is the difference between the highest and the second highest Aid flow (current US$) of 1992?
Provide a short and direct response. 0. What is the difference between the highest and the second highest Aid flow (current US$) of 1994?
Ensure brevity in your answer.  0. What is the difference between the highest and the second highest Aid flow (current US$) in 1997?
Make the answer very short. 0. What is the difference between the highest and the lowest Aid flow (current US$) in 1992?
Your answer should be compact. 8.50e+05. What is the difference between the highest and the lowest Aid flow (current US$) in 1994?
Your answer should be very brief. 8.10e+05. What is the difference between the highest and the lowest Aid flow (current US$) in 1998?
Keep it short and to the point. 9.40e+05. 